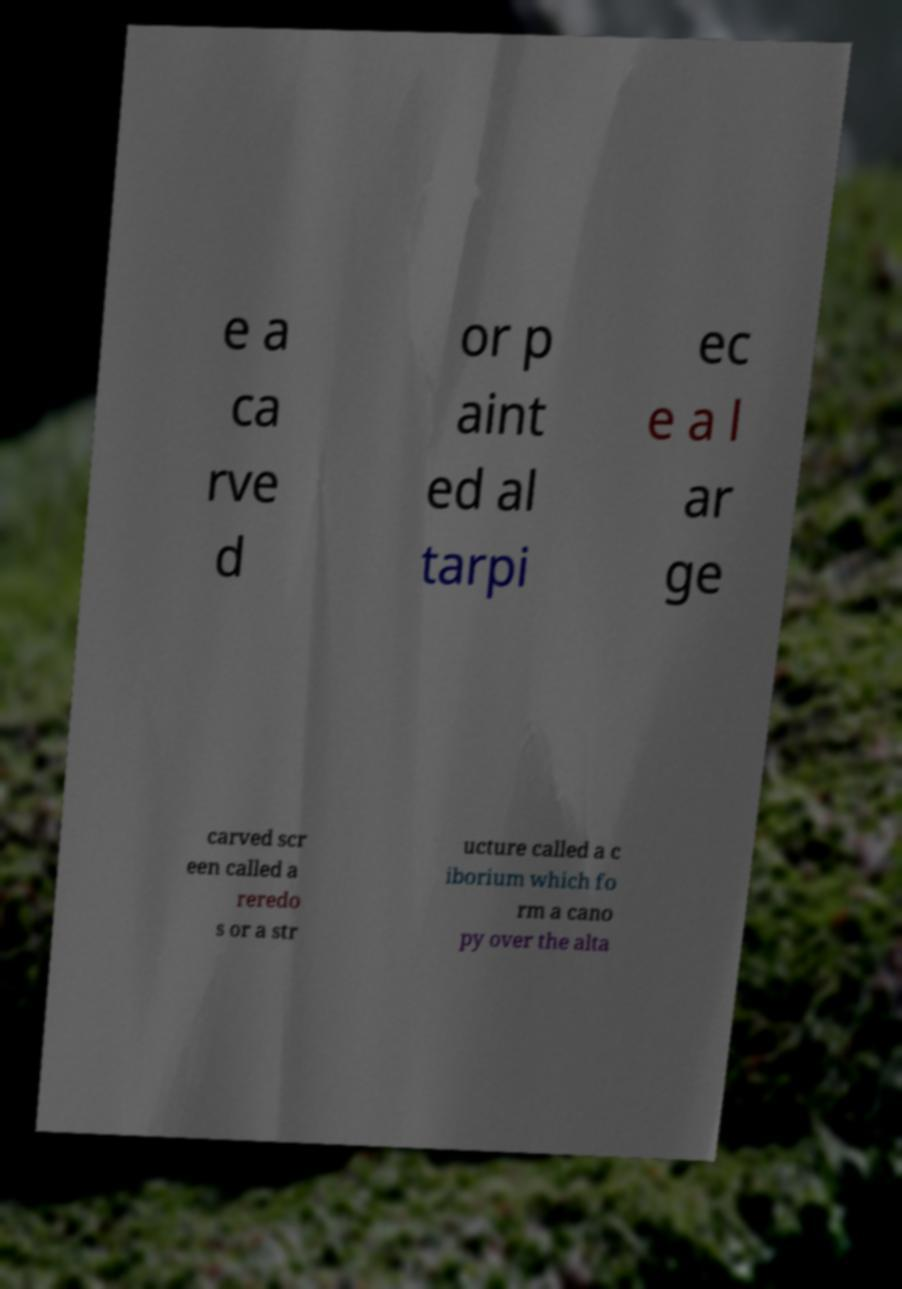Please identify and transcribe the text found in this image. e a ca rve d or p aint ed al tarpi ec e a l ar ge carved scr een called a reredo s or a str ucture called a c iborium which fo rm a cano py over the alta 